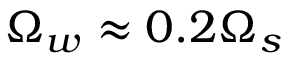<formula> <loc_0><loc_0><loc_500><loc_500>\Omega _ { w } \approx 0 . 2 \Omega _ { s }</formula> 